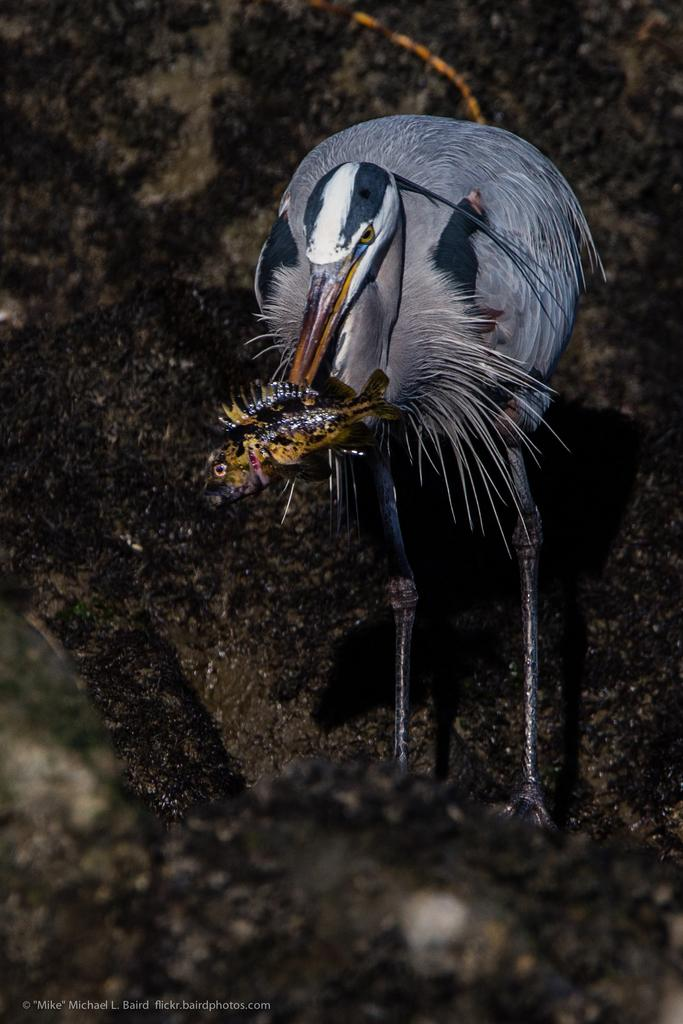What type of animal is present in the image? There is a bird in the image. What is the bird holding in its beak? The bird is holding a fish. What can be seen at the bottom of the image? There are stones at the bottom of the image. Where is the text located in the image? The text is at the bottom left of the image. What type of regret can be seen on the bird's face in the image? There is no indication of regret on the bird's face in the image. Is there a ship visible in the image? No, there is no ship present in the image. 